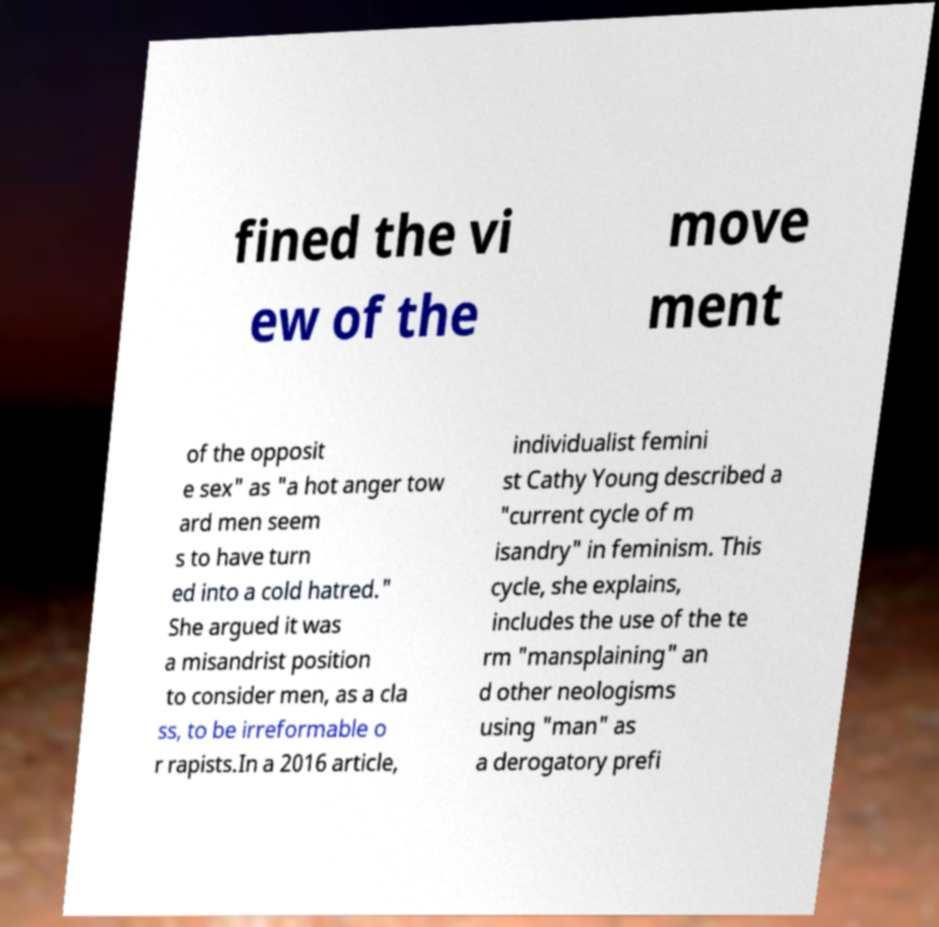Please read and relay the text visible in this image. What does it say? fined the vi ew of the move ment of the opposit e sex" as "a hot anger tow ard men seem s to have turn ed into a cold hatred." She argued it was a misandrist position to consider men, as a cla ss, to be irreformable o r rapists.In a 2016 article, individualist femini st Cathy Young described a "current cycle of m isandry" in feminism. This cycle, she explains, includes the use of the te rm "mansplaining" an d other neologisms using "man" as a derogatory prefi 